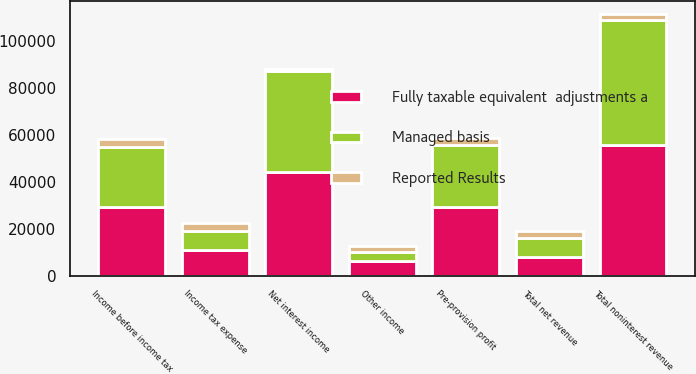<chart> <loc_0><loc_0><loc_500><loc_500><stacked_bar_chart><ecel><fcel>Other income<fcel>Total noninterest revenue<fcel>Net interest income<fcel>Total net revenue<fcel>Pre-provision profit<fcel>Income before income tax<fcel>Income tax expense<nl><fcel>Managed basis<fcel>3847<fcel>53287<fcel>43319<fcel>7991<fcel>26139<fcel>25914<fcel>7991<nl><fcel>Reported Results<fcel>2495<fcel>2495<fcel>697<fcel>3192<fcel>3192<fcel>3192<fcel>3192<nl><fcel>Fully taxable equivalent  adjustments a<fcel>6342<fcel>55782<fcel>44016<fcel>7991<fcel>29331<fcel>29106<fcel>11183<nl></chart> 